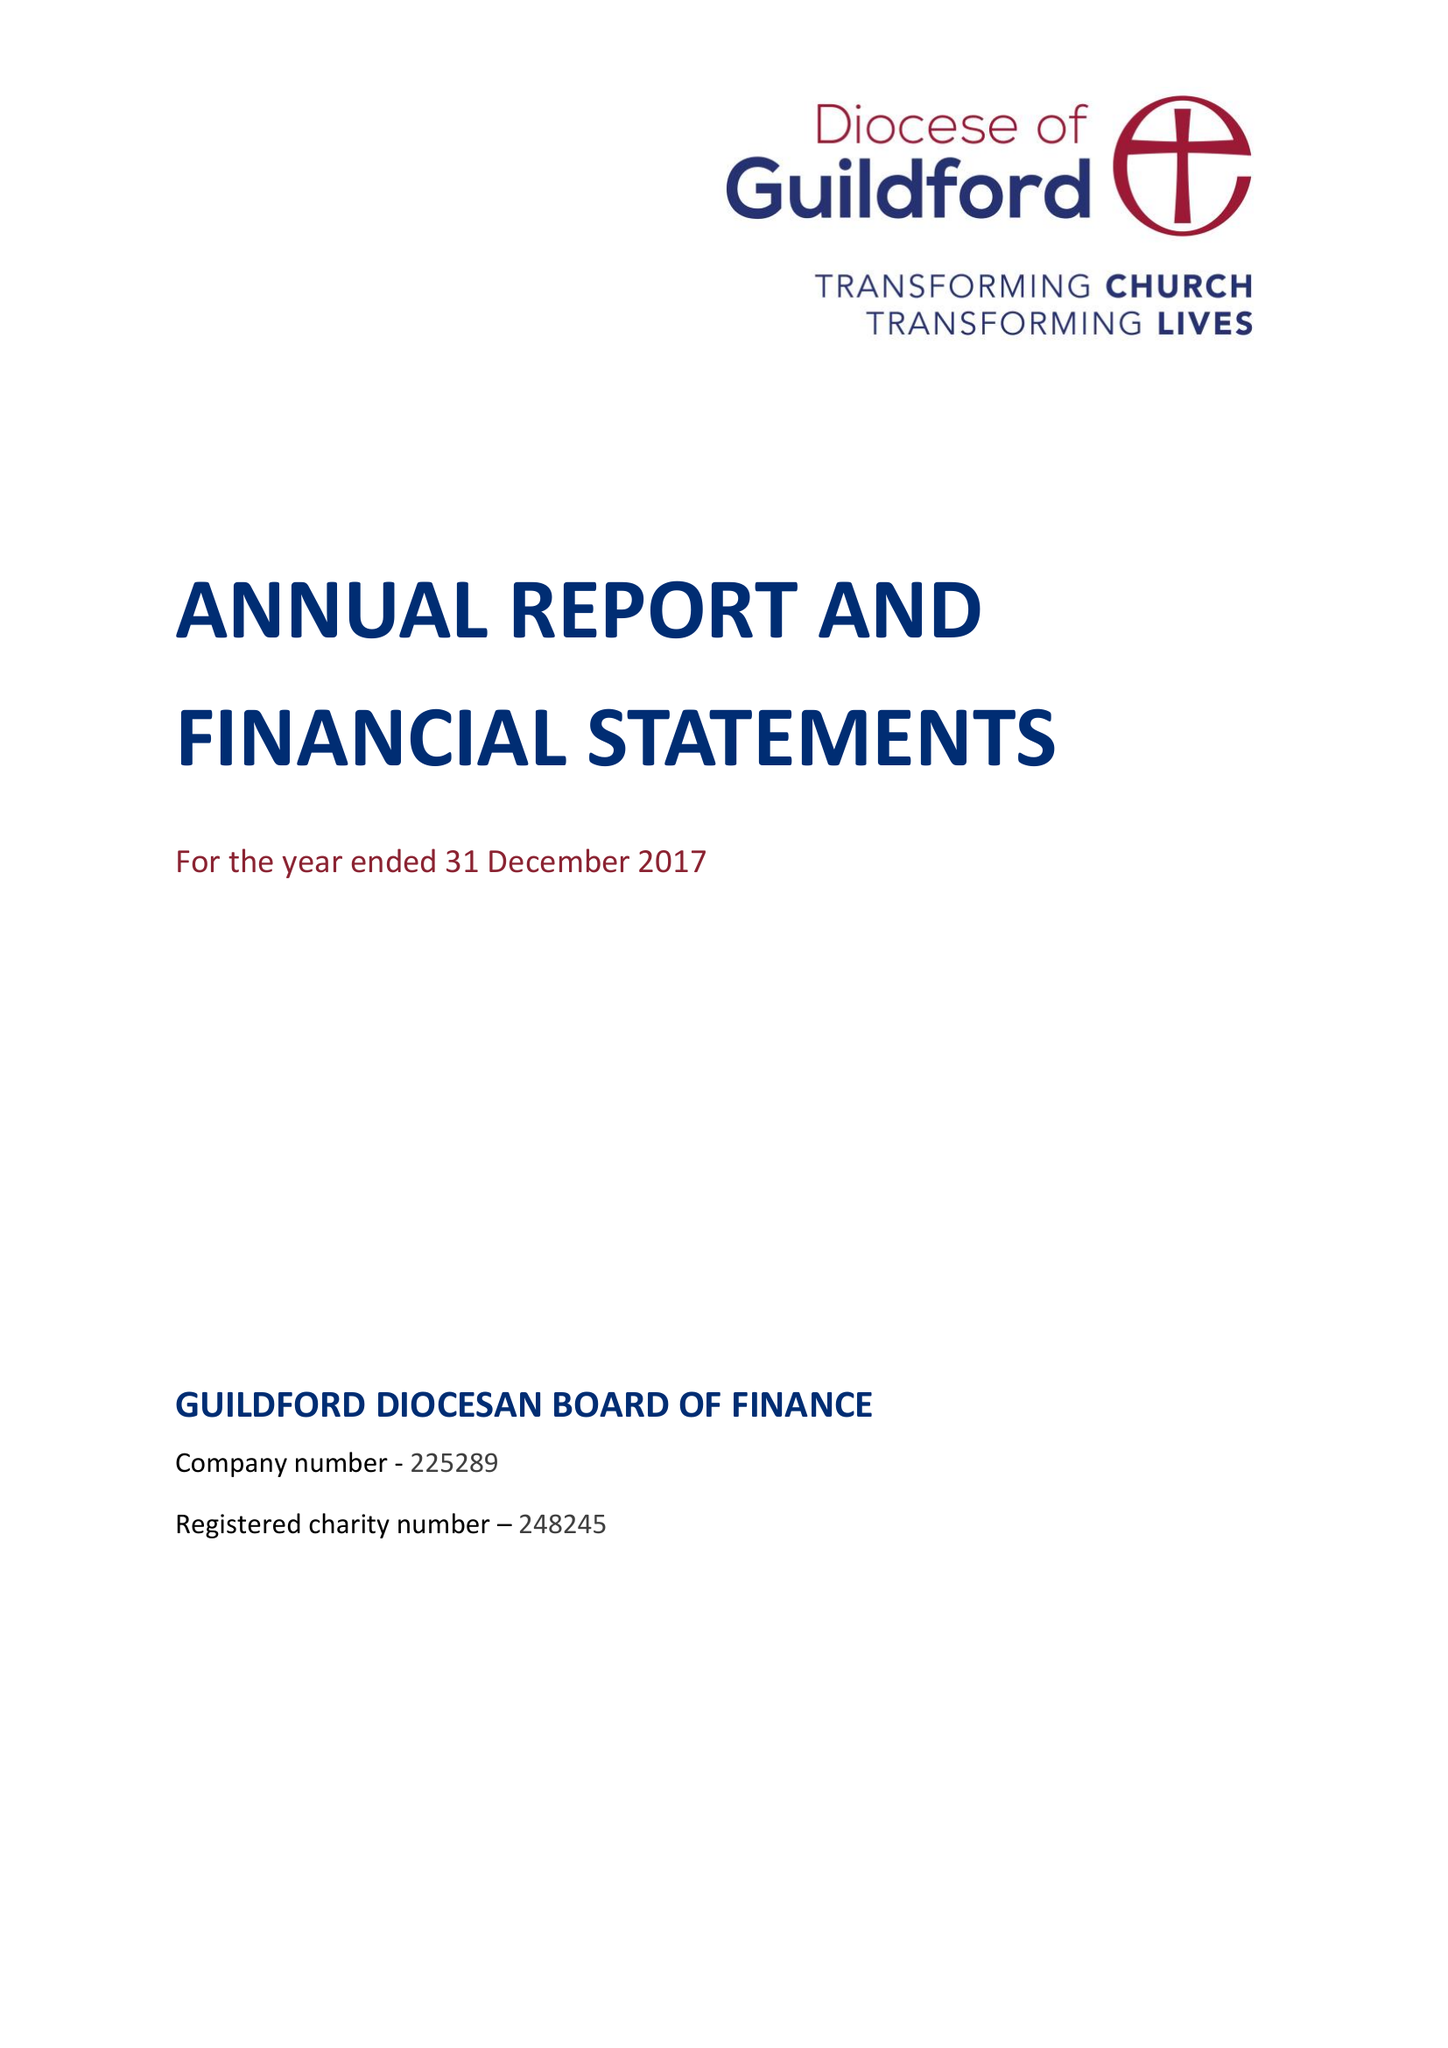What is the value for the income_annually_in_british_pounds?
Answer the question using a single word or phrase. 14399000.00 